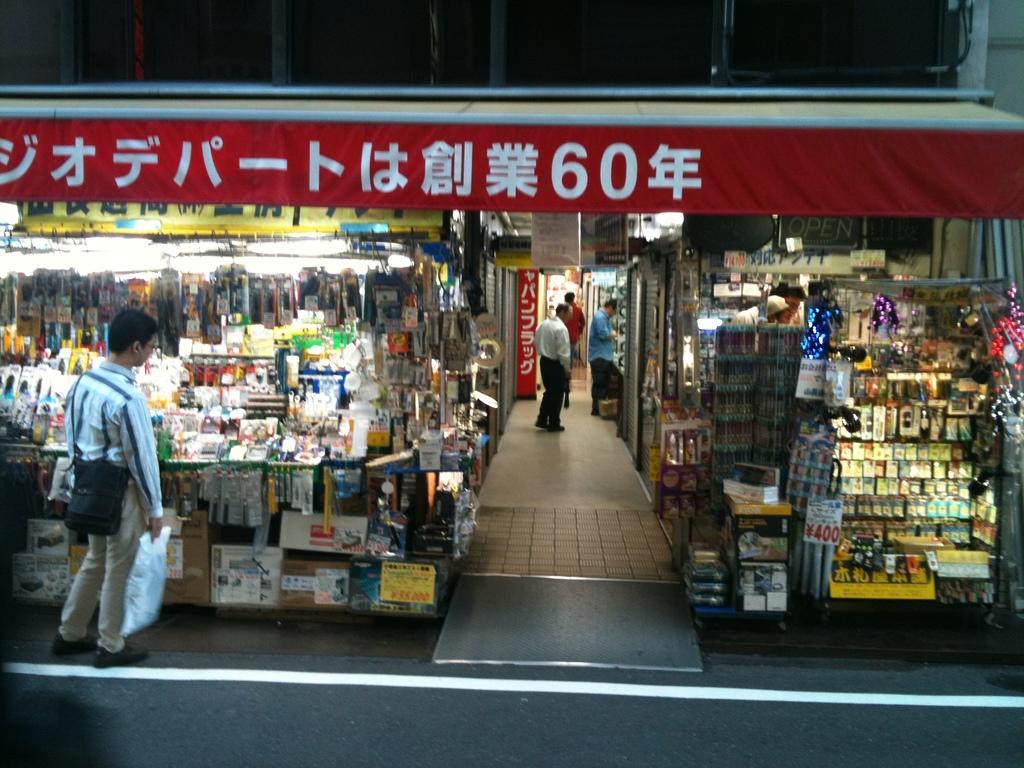How would you summarize this image in a sentence or two? In this image we can see there are stalls on the left and right side of the image. On the left side of the image there is a person standing with cover in front of the stall. In the middle of the stalls there are three people standing. At the bottom of the image there is a road. 